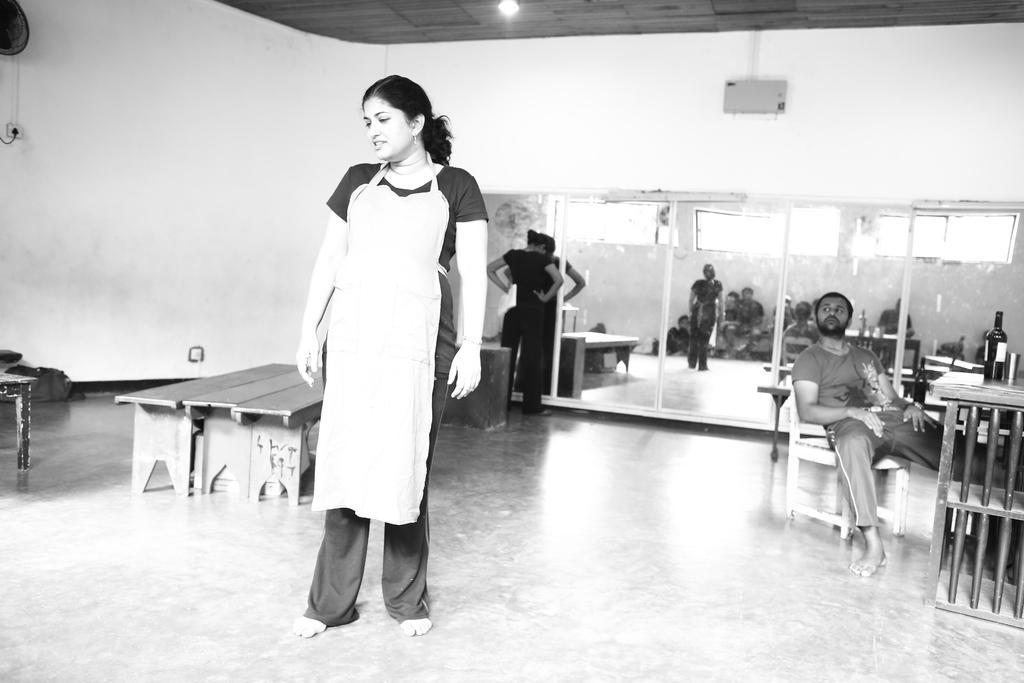How would you summarize this image in a sentence or two? a person is standing wearing a apron. right to her on a table there is a glass bottle and a steel glass. a person is sitting on the chair in front of the table. at the left there are 3 wooden tables. behind that there is a wall on which there is a fan. and at the back there is a mirror. a person wearing black dress is standing in front of the mirror, holding a paper in her hand. 